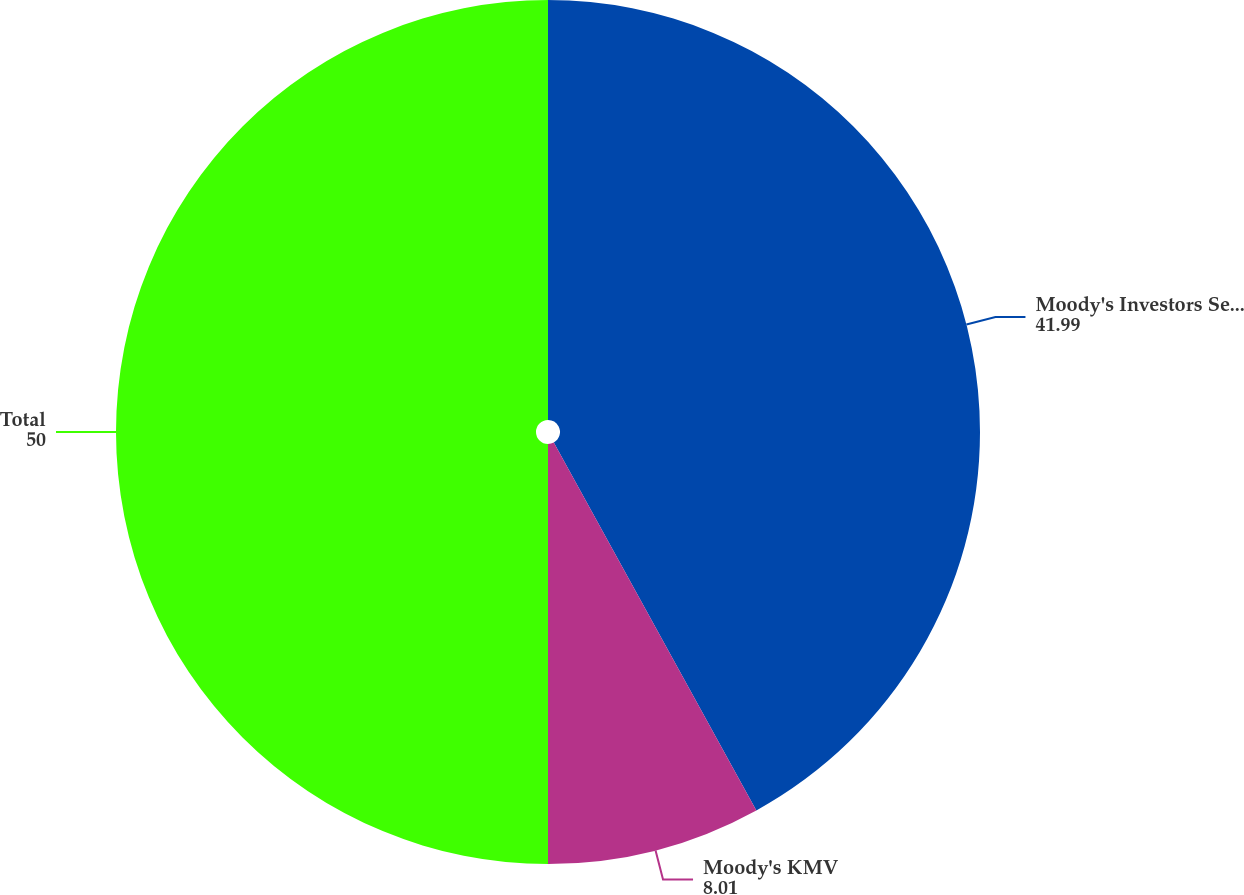<chart> <loc_0><loc_0><loc_500><loc_500><pie_chart><fcel>Moody's Investors Service<fcel>Moody's KMV<fcel>Total<nl><fcel>41.99%<fcel>8.01%<fcel>50.0%<nl></chart> 